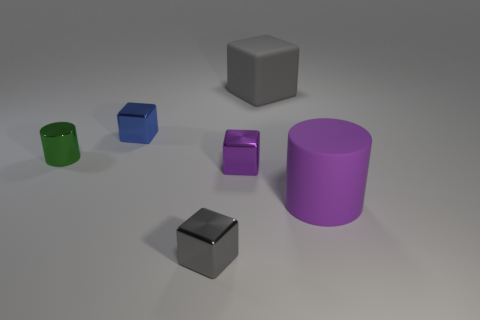There is a thing that is to the right of the small purple metallic cube and behind the green thing; what size is it? The object to the right of the small purple metallic cube and behind the green object is a large blue cube. Given its spatial relation to the other objects, it appears to be significantly larger in comparison, thus qualifying it as 'large'. 